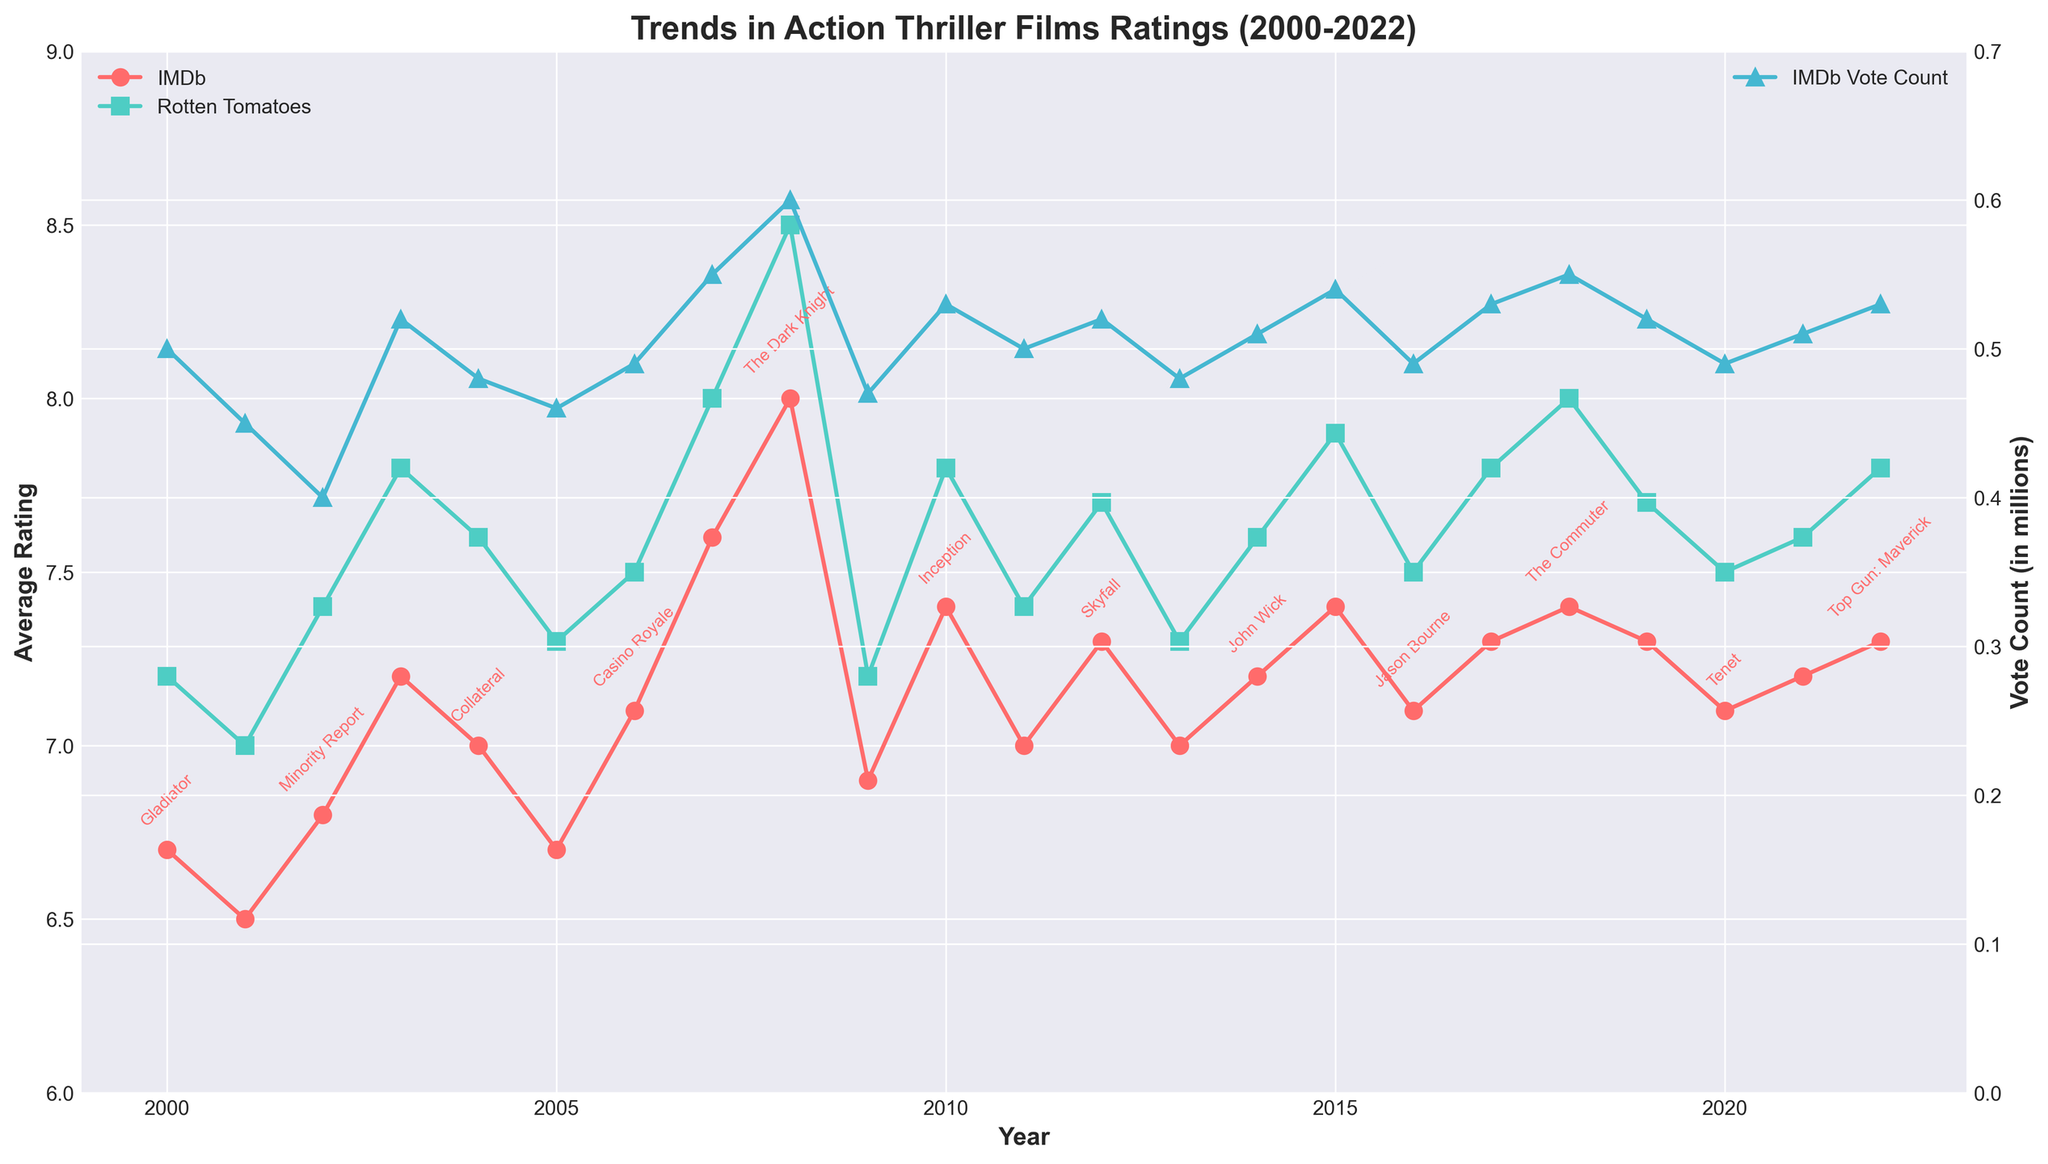What is the maximum IMDb average rating shown on the plot? The highest IMDb average rating is identified by looking at the peak of the IMDb line on the plot, which appears to be in 2008 for "The Dark Knight".
Answer: 8.0 Which years show an increase in IMDb vote count compared to the preceding year? By observing the plot, an increase in IMDb vote count is observed where the line graph shows an upward trend year-over-year. These appear from 2003 to 2004, 2006 to 2007, 2007 to 2008, 2008 to 2009, 2013 to 2014, 2014 to 2015, 2017 to 2018, and 2021 to 2022.
Answer: 2003-2004, 2006-2007, 2007-2008, 2008-2009, 2013-2014, 2014-2015, 2017-2018, 2021-2022 In which year did Rotten Tomatoes have the lowest average rating for action thriller films? Check the plotted Rotten Tomatoes average rating line and identify the year where the line is at its lowest position. This occurs in 2001.
Answer: 2001 How does the trend of IMDb average ratings compare to Rotten Tomatoes average ratings over the years? Observing both lines, the IMDb ratings consistently fall within a similar range and generally align with Rotten Tomatoes trends, exhibiting parallel increases and decreases over the years.
Answer: Similar trend with parallel increases and decreases What is the most common range for IMDb average ratings over the years? By examining the spikes and troughs of the IMDb average rating line on the plot, most values lie between 7.0 and 7.4.
Answer: 7.0 to 7.4 Are there any years where both IMDb and Rotten Tomatoes average ratings increased significantly? Compare corresponding points on both the IMDb and Rotten Tomatoes average rating lines to find years where both lines show a marked upward trend. This occurs from 2007 to 2008.
Answer: 2007 to 2008 Which action thriller film had the highest combined average rating from IMDb and Rotten Tomatoes in one year? Identify the film associated with the year having the highest IMDb and Rotten Tomatoes averages combined. The highest combined rating appears in 2008 for "The Dark Knight".
Answer: The Dark Knight (2008) Did IMDb vote count show consistent growth over the years? Follow the IMDb vote count line graph; while there are periods of increase, there are also years of decline, indicating inconsistent growth.
Answer: No 